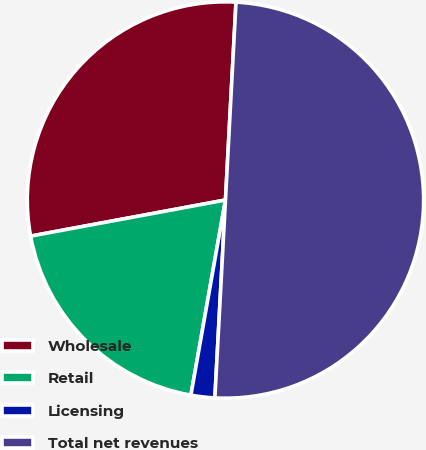Convert chart. <chart><loc_0><loc_0><loc_500><loc_500><pie_chart><fcel>Wholesale<fcel>Retail<fcel>Licensing<fcel>Total net revenues<nl><fcel>28.76%<fcel>19.29%<fcel>1.94%<fcel>50.0%<nl></chart> 